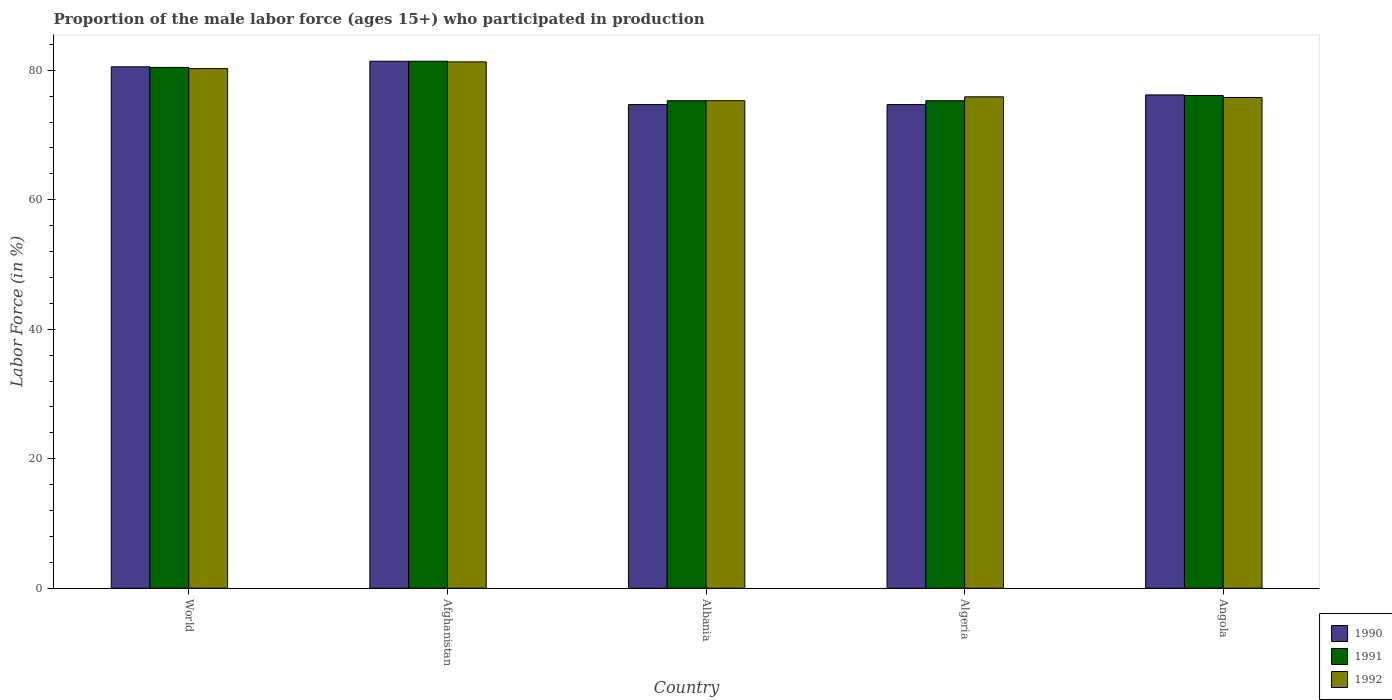How many different coloured bars are there?
Give a very brief answer. 3. How many groups of bars are there?
Offer a very short reply. 5. Are the number of bars per tick equal to the number of legend labels?
Give a very brief answer. Yes. How many bars are there on the 3rd tick from the right?
Ensure brevity in your answer.  3. What is the label of the 1st group of bars from the left?
Provide a short and direct response. World. What is the proportion of the male labor force who participated in production in 1990 in Afghanistan?
Make the answer very short. 81.4. Across all countries, what is the maximum proportion of the male labor force who participated in production in 1991?
Provide a succinct answer. 81.4. Across all countries, what is the minimum proportion of the male labor force who participated in production in 1990?
Offer a terse response. 74.7. In which country was the proportion of the male labor force who participated in production in 1990 maximum?
Your answer should be very brief. Afghanistan. In which country was the proportion of the male labor force who participated in production in 1992 minimum?
Offer a very short reply. Albania. What is the total proportion of the male labor force who participated in production in 1992 in the graph?
Make the answer very short. 388.56. What is the difference between the proportion of the male labor force who participated in production in 1991 in Afghanistan and that in Angola?
Give a very brief answer. 5.3. What is the difference between the proportion of the male labor force who participated in production in 1990 in Algeria and the proportion of the male labor force who participated in production in 1991 in Albania?
Make the answer very short. -0.6. What is the average proportion of the male labor force who participated in production in 1991 per country?
Provide a short and direct response. 77.71. What is the difference between the proportion of the male labor force who participated in production of/in 1992 and proportion of the male labor force who participated in production of/in 1990 in World?
Keep it short and to the point. -0.28. In how many countries, is the proportion of the male labor force who participated in production in 1990 greater than 68 %?
Offer a very short reply. 5. What is the ratio of the proportion of the male labor force who participated in production in 1992 in Angola to that in World?
Give a very brief answer. 0.94. Is the proportion of the male labor force who participated in production in 1990 in Albania less than that in World?
Provide a succinct answer. Yes. What is the difference between the highest and the second highest proportion of the male labor force who participated in production in 1991?
Offer a very short reply. -0.96. What is the difference between the highest and the lowest proportion of the male labor force who participated in production in 1991?
Give a very brief answer. 6.1. In how many countries, is the proportion of the male labor force who participated in production in 1991 greater than the average proportion of the male labor force who participated in production in 1991 taken over all countries?
Provide a succinct answer. 2. Are all the bars in the graph horizontal?
Offer a terse response. No. Are the values on the major ticks of Y-axis written in scientific E-notation?
Provide a succinct answer. No. Does the graph contain any zero values?
Your response must be concise. No. Where does the legend appear in the graph?
Ensure brevity in your answer.  Bottom right. How are the legend labels stacked?
Keep it short and to the point. Vertical. What is the title of the graph?
Provide a succinct answer. Proportion of the male labor force (ages 15+) who participated in production. Does "1969" appear as one of the legend labels in the graph?
Provide a succinct answer. No. What is the label or title of the X-axis?
Your response must be concise. Country. What is the Labor Force (in %) of 1990 in World?
Ensure brevity in your answer.  80.54. What is the Labor Force (in %) of 1991 in World?
Offer a terse response. 80.44. What is the Labor Force (in %) in 1992 in World?
Give a very brief answer. 80.26. What is the Labor Force (in %) in 1990 in Afghanistan?
Your response must be concise. 81.4. What is the Labor Force (in %) in 1991 in Afghanistan?
Provide a short and direct response. 81.4. What is the Labor Force (in %) in 1992 in Afghanistan?
Make the answer very short. 81.3. What is the Labor Force (in %) in 1990 in Albania?
Your answer should be very brief. 74.7. What is the Labor Force (in %) of 1991 in Albania?
Your answer should be compact. 75.3. What is the Labor Force (in %) of 1992 in Albania?
Offer a terse response. 75.3. What is the Labor Force (in %) in 1990 in Algeria?
Provide a short and direct response. 74.7. What is the Labor Force (in %) of 1991 in Algeria?
Offer a very short reply. 75.3. What is the Labor Force (in %) in 1992 in Algeria?
Your answer should be very brief. 75.9. What is the Labor Force (in %) of 1990 in Angola?
Provide a short and direct response. 76.2. What is the Labor Force (in %) in 1991 in Angola?
Make the answer very short. 76.1. What is the Labor Force (in %) in 1992 in Angola?
Make the answer very short. 75.8. Across all countries, what is the maximum Labor Force (in %) in 1990?
Give a very brief answer. 81.4. Across all countries, what is the maximum Labor Force (in %) of 1991?
Make the answer very short. 81.4. Across all countries, what is the maximum Labor Force (in %) of 1992?
Your answer should be compact. 81.3. Across all countries, what is the minimum Labor Force (in %) in 1990?
Your response must be concise. 74.7. Across all countries, what is the minimum Labor Force (in %) in 1991?
Make the answer very short. 75.3. Across all countries, what is the minimum Labor Force (in %) in 1992?
Ensure brevity in your answer.  75.3. What is the total Labor Force (in %) in 1990 in the graph?
Your answer should be very brief. 387.54. What is the total Labor Force (in %) of 1991 in the graph?
Ensure brevity in your answer.  388.54. What is the total Labor Force (in %) in 1992 in the graph?
Your answer should be compact. 388.56. What is the difference between the Labor Force (in %) in 1990 in World and that in Afghanistan?
Ensure brevity in your answer.  -0.86. What is the difference between the Labor Force (in %) in 1991 in World and that in Afghanistan?
Ensure brevity in your answer.  -0.96. What is the difference between the Labor Force (in %) of 1992 in World and that in Afghanistan?
Your answer should be compact. -1.04. What is the difference between the Labor Force (in %) in 1990 in World and that in Albania?
Your answer should be very brief. 5.84. What is the difference between the Labor Force (in %) in 1991 in World and that in Albania?
Your response must be concise. 5.14. What is the difference between the Labor Force (in %) in 1992 in World and that in Albania?
Give a very brief answer. 4.96. What is the difference between the Labor Force (in %) in 1990 in World and that in Algeria?
Offer a very short reply. 5.84. What is the difference between the Labor Force (in %) in 1991 in World and that in Algeria?
Give a very brief answer. 5.14. What is the difference between the Labor Force (in %) in 1992 in World and that in Algeria?
Your response must be concise. 4.36. What is the difference between the Labor Force (in %) of 1990 in World and that in Angola?
Make the answer very short. 4.34. What is the difference between the Labor Force (in %) in 1991 in World and that in Angola?
Ensure brevity in your answer.  4.34. What is the difference between the Labor Force (in %) in 1992 in World and that in Angola?
Provide a short and direct response. 4.46. What is the difference between the Labor Force (in %) of 1991 in Afghanistan and that in Albania?
Your answer should be compact. 6.1. What is the difference between the Labor Force (in %) of 1990 in Afghanistan and that in Algeria?
Make the answer very short. 6.7. What is the difference between the Labor Force (in %) in 1991 in Afghanistan and that in Algeria?
Make the answer very short. 6.1. What is the difference between the Labor Force (in %) in 1992 in Afghanistan and that in Angola?
Give a very brief answer. 5.5. What is the difference between the Labor Force (in %) of 1990 in Albania and that in Algeria?
Your response must be concise. 0. What is the difference between the Labor Force (in %) in 1991 in Albania and that in Angola?
Your answer should be very brief. -0.8. What is the difference between the Labor Force (in %) of 1991 in Algeria and that in Angola?
Keep it short and to the point. -0.8. What is the difference between the Labor Force (in %) of 1992 in Algeria and that in Angola?
Provide a succinct answer. 0.1. What is the difference between the Labor Force (in %) of 1990 in World and the Labor Force (in %) of 1991 in Afghanistan?
Ensure brevity in your answer.  -0.86. What is the difference between the Labor Force (in %) in 1990 in World and the Labor Force (in %) in 1992 in Afghanistan?
Provide a short and direct response. -0.76. What is the difference between the Labor Force (in %) in 1991 in World and the Labor Force (in %) in 1992 in Afghanistan?
Offer a very short reply. -0.86. What is the difference between the Labor Force (in %) in 1990 in World and the Labor Force (in %) in 1991 in Albania?
Give a very brief answer. 5.24. What is the difference between the Labor Force (in %) in 1990 in World and the Labor Force (in %) in 1992 in Albania?
Offer a terse response. 5.24. What is the difference between the Labor Force (in %) in 1991 in World and the Labor Force (in %) in 1992 in Albania?
Ensure brevity in your answer.  5.14. What is the difference between the Labor Force (in %) in 1990 in World and the Labor Force (in %) in 1991 in Algeria?
Your response must be concise. 5.24. What is the difference between the Labor Force (in %) of 1990 in World and the Labor Force (in %) of 1992 in Algeria?
Provide a succinct answer. 4.64. What is the difference between the Labor Force (in %) in 1991 in World and the Labor Force (in %) in 1992 in Algeria?
Your response must be concise. 4.54. What is the difference between the Labor Force (in %) of 1990 in World and the Labor Force (in %) of 1991 in Angola?
Your response must be concise. 4.44. What is the difference between the Labor Force (in %) of 1990 in World and the Labor Force (in %) of 1992 in Angola?
Offer a terse response. 4.74. What is the difference between the Labor Force (in %) in 1991 in World and the Labor Force (in %) in 1992 in Angola?
Offer a terse response. 4.64. What is the difference between the Labor Force (in %) of 1990 in Afghanistan and the Labor Force (in %) of 1991 in Albania?
Make the answer very short. 6.1. What is the difference between the Labor Force (in %) in 1991 in Afghanistan and the Labor Force (in %) in 1992 in Algeria?
Your answer should be very brief. 5.5. What is the difference between the Labor Force (in %) in 1990 in Afghanistan and the Labor Force (in %) in 1991 in Angola?
Ensure brevity in your answer.  5.3. What is the difference between the Labor Force (in %) in 1991 in Afghanistan and the Labor Force (in %) in 1992 in Angola?
Ensure brevity in your answer.  5.6. What is the difference between the Labor Force (in %) in 1990 in Albania and the Labor Force (in %) in 1991 in Algeria?
Keep it short and to the point. -0.6. What is the difference between the Labor Force (in %) in 1990 in Albania and the Labor Force (in %) in 1992 in Algeria?
Keep it short and to the point. -1.2. What is the difference between the Labor Force (in %) in 1990 in Albania and the Labor Force (in %) in 1991 in Angola?
Your answer should be very brief. -1.4. What is the difference between the Labor Force (in %) of 1990 in Albania and the Labor Force (in %) of 1992 in Angola?
Your answer should be compact. -1.1. What is the difference between the Labor Force (in %) of 1991 in Albania and the Labor Force (in %) of 1992 in Angola?
Offer a very short reply. -0.5. What is the average Labor Force (in %) in 1990 per country?
Provide a short and direct response. 77.51. What is the average Labor Force (in %) in 1991 per country?
Ensure brevity in your answer.  77.71. What is the average Labor Force (in %) of 1992 per country?
Provide a short and direct response. 77.71. What is the difference between the Labor Force (in %) of 1990 and Labor Force (in %) of 1991 in World?
Your answer should be very brief. 0.1. What is the difference between the Labor Force (in %) in 1990 and Labor Force (in %) in 1992 in World?
Make the answer very short. 0.28. What is the difference between the Labor Force (in %) of 1991 and Labor Force (in %) of 1992 in World?
Make the answer very short. 0.18. What is the difference between the Labor Force (in %) of 1990 and Labor Force (in %) of 1991 in Afghanistan?
Offer a very short reply. 0. What is the difference between the Labor Force (in %) of 1991 and Labor Force (in %) of 1992 in Afghanistan?
Your answer should be compact. 0.1. What is the difference between the Labor Force (in %) of 1990 and Labor Force (in %) of 1991 in Albania?
Your response must be concise. -0.6. What is the difference between the Labor Force (in %) of 1990 and Labor Force (in %) of 1992 in Albania?
Your answer should be compact. -0.6. What is the difference between the Labor Force (in %) of 1990 and Labor Force (in %) of 1991 in Algeria?
Provide a short and direct response. -0.6. What is the difference between the Labor Force (in %) of 1990 and Labor Force (in %) of 1992 in Angola?
Your response must be concise. 0.4. What is the ratio of the Labor Force (in %) of 1990 in World to that in Afghanistan?
Give a very brief answer. 0.99. What is the ratio of the Labor Force (in %) of 1991 in World to that in Afghanistan?
Provide a succinct answer. 0.99. What is the ratio of the Labor Force (in %) in 1992 in World to that in Afghanistan?
Offer a very short reply. 0.99. What is the ratio of the Labor Force (in %) in 1990 in World to that in Albania?
Keep it short and to the point. 1.08. What is the ratio of the Labor Force (in %) of 1991 in World to that in Albania?
Offer a very short reply. 1.07. What is the ratio of the Labor Force (in %) in 1992 in World to that in Albania?
Provide a succinct answer. 1.07. What is the ratio of the Labor Force (in %) of 1990 in World to that in Algeria?
Give a very brief answer. 1.08. What is the ratio of the Labor Force (in %) of 1991 in World to that in Algeria?
Your answer should be compact. 1.07. What is the ratio of the Labor Force (in %) in 1992 in World to that in Algeria?
Make the answer very short. 1.06. What is the ratio of the Labor Force (in %) in 1990 in World to that in Angola?
Your answer should be very brief. 1.06. What is the ratio of the Labor Force (in %) in 1991 in World to that in Angola?
Keep it short and to the point. 1.06. What is the ratio of the Labor Force (in %) of 1992 in World to that in Angola?
Offer a very short reply. 1.06. What is the ratio of the Labor Force (in %) of 1990 in Afghanistan to that in Albania?
Your answer should be compact. 1.09. What is the ratio of the Labor Force (in %) of 1991 in Afghanistan to that in Albania?
Offer a terse response. 1.08. What is the ratio of the Labor Force (in %) in 1992 in Afghanistan to that in Albania?
Your response must be concise. 1.08. What is the ratio of the Labor Force (in %) of 1990 in Afghanistan to that in Algeria?
Give a very brief answer. 1.09. What is the ratio of the Labor Force (in %) in 1991 in Afghanistan to that in Algeria?
Offer a very short reply. 1.08. What is the ratio of the Labor Force (in %) of 1992 in Afghanistan to that in Algeria?
Ensure brevity in your answer.  1.07. What is the ratio of the Labor Force (in %) of 1990 in Afghanistan to that in Angola?
Give a very brief answer. 1.07. What is the ratio of the Labor Force (in %) in 1991 in Afghanistan to that in Angola?
Make the answer very short. 1.07. What is the ratio of the Labor Force (in %) in 1992 in Afghanistan to that in Angola?
Provide a succinct answer. 1.07. What is the ratio of the Labor Force (in %) in 1991 in Albania to that in Algeria?
Your answer should be very brief. 1. What is the ratio of the Labor Force (in %) of 1990 in Albania to that in Angola?
Give a very brief answer. 0.98. What is the ratio of the Labor Force (in %) in 1992 in Albania to that in Angola?
Ensure brevity in your answer.  0.99. What is the ratio of the Labor Force (in %) of 1990 in Algeria to that in Angola?
Provide a short and direct response. 0.98. What is the ratio of the Labor Force (in %) in 1991 in Algeria to that in Angola?
Provide a succinct answer. 0.99. What is the difference between the highest and the second highest Labor Force (in %) of 1990?
Your answer should be compact. 0.86. What is the difference between the highest and the second highest Labor Force (in %) in 1991?
Your answer should be very brief. 0.96. What is the difference between the highest and the second highest Labor Force (in %) of 1992?
Your answer should be very brief. 1.04. What is the difference between the highest and the lowest Labor Force (in %) in 1990?
Keep it short and to the point. 6.7. 